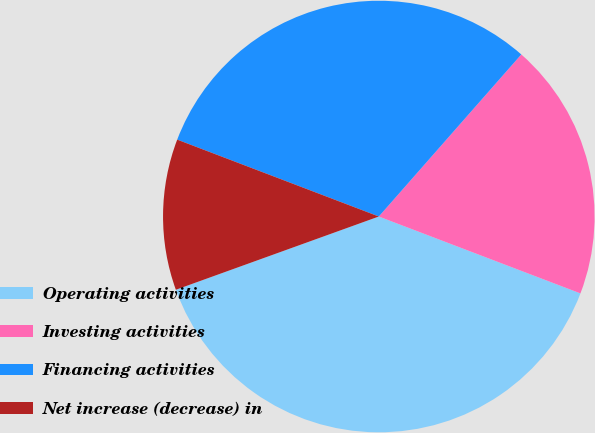Convert chart. <chart><loc_0><loc_0><loc_500><loc_500><pie_chart><fcel>Operating activities<fcel>Investing activities<fcel>Financing activities<fcel>Net increase (decrease) in<nl><fcel>38.69%<fcel>19.32%<fcel>30.68%<fcel>11.31%<nl></chart> 